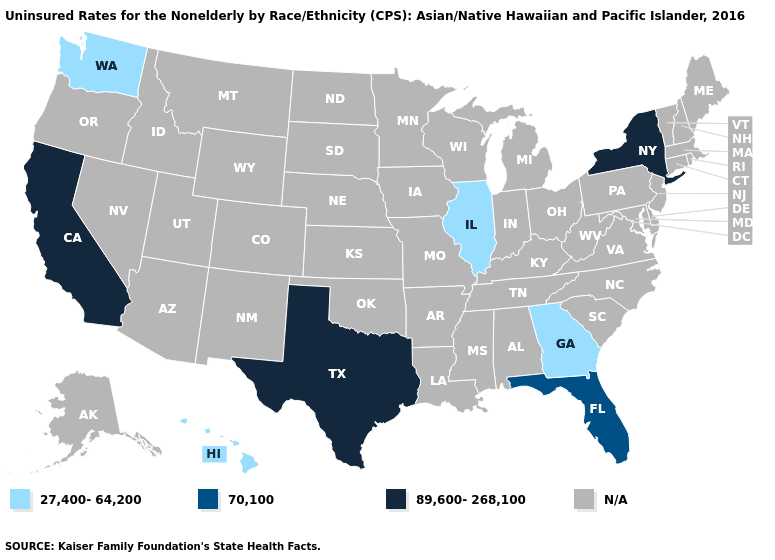What is the value of Delaware?
Keep it brief. N/A. What is the value of Tennessee?
Short answer required. N/A. What is the value of Wisconsin?
Short answer required. N/A. What is the highest value in the West ?
Write a very short answer. 89,600-268,100. Name the states that have a value in the range 89,600-268,100?
Short answer required. California, New York, Texas. Name the states that have a value in the range 89,600-268,100?
Be succinct. California, New York, Texas. Is the legend a continuous bar?
Short answer required. No. Does Hawaii have the highest value in the West?
Concise answer only. No. What is the value of South Dakota?
Keep it brief. N/A. Is the legend a continuous bar?
Short answer required. No. Does the map have missing data?
Quick response, please. Yes. What is the value of Vermont?
Quick response, please. N/A. What is the value of New York?
Give a very brief answer. 89,600-268,100. 